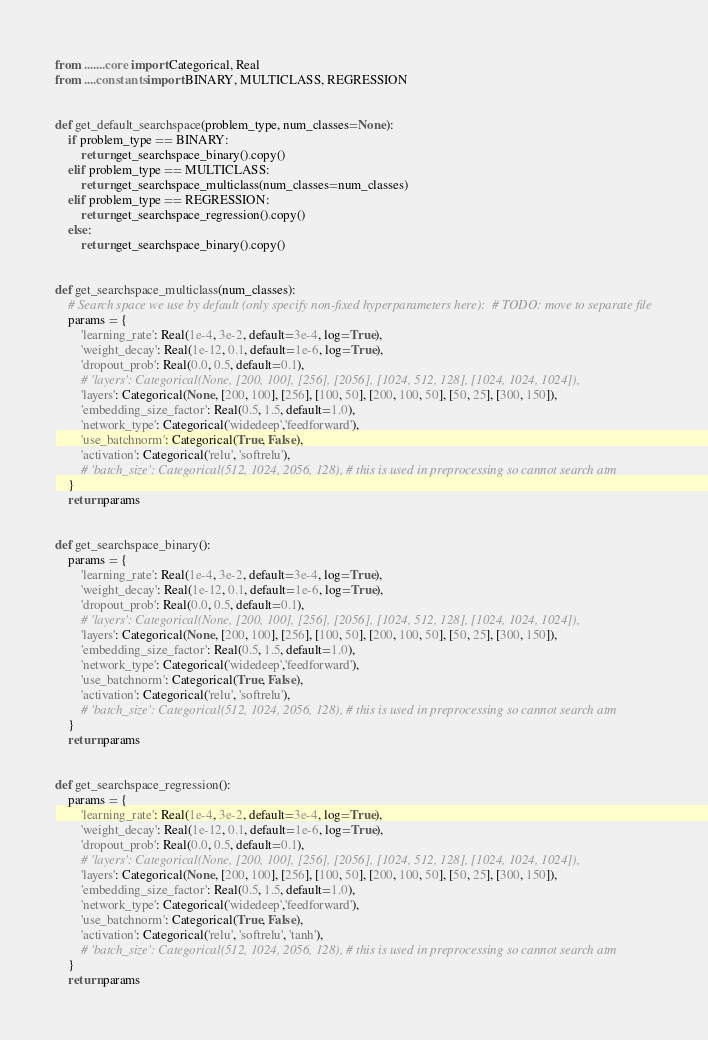<code> <loc_0><loc_0><loc_500><loc_500><_Python_>from .......core import Categorical, Real
from ....constants import BINARY, MULTICLASS, REGRESSION


def get_default_searchspace(problem_type, num_classes=None):
    if problem_type == BINARY:
        return get_searchspace_binary().copy()
    elif problem_type == MULTICLASS:
        return get_searchspace_multiclass(num_classes=num_classes)
    elif problem_type == REGRESSION:
        return get_searchspace_regression().copy()
    else:
        return get_searchspace_binary().copy()


def get_searchspace_multiclass(num_classes):
    # Search space we use by default (only specify non-fixed hyperparameters here):  # TODO: move to separate file
    params = {
        'learning_rate': Real(1e-4, 3e-2, default=3e-4, log=True),
        'weight_decay': Real(1e-12, 0.1, default=1e-6, log=True),
        'dropout_prob': Real(0.0, 0.5, default=0.1),
        # 'layers': Categorical(None, [200, 100], [256], [2056], [1024, 512, 128], [1024, 1024, 1024]),
        'layers': Categorical(None, [200, 100], [256], [100, 50], [200, 100, 50], [50, 25], [300, 150]),
        'embedding_size_factor': Real(0.5, 1.5, default=1.0),
        'network_type': Categorical('widedeep','feedforward'), 
        'use_batchnorm': Categorical(True, False),
        'activation': Categorical('relu', 'softrelu'),
        # 'batch_size': Categorical(512, 1024, 2056, 128), # this is used in preprocessing so cannot search atm
    }
    return params


def get_searchspace_binary():
    params = {
        'learning_rate': Real(1e-4, 3e-2, default=3e-4, log=True),
        'weight_decay': Real(1e-12, 0.1, default=1e-6, log=True),
        'dropout_prob': Real(0.0, 0.5, default=0.1),
        # 'layers': Categorical(None, [200, 100], [256], [2056], [1024, 512, 128], [1024, 1024, 1024]),
        'layers': Categorical(None, [200, 100], [256], [100, 50], [200, 100, 50], [50, 25], [300, 150]),
        'embedding_size_factor': Real(0.5, 1.5, default=1.0),
        'network_type': Categorical('widedeep','feedforward'), 
        'use_batchnorm': Categorical(True, False),
        'activation': Categorical('relu', 'softrelu'),
        # 'batch_size': Categorical(512, 1024, 2056, 128), # this is used in preprocessing so cannot search atm
    }
    return params


def get_searchspace_regression():
    params = {
        'learning_rate': Real(1e-4, 3e-2, default=3e-4, log=True),
        'weight_decay': Real(1e-12, 0.1, default=1e-6, log=True),
        'dropout_prob': Real(0.0, 0.5, default=0.1),
        # 'layers': Categorical(None, [200, 100], [256], [2056], [1024, 512, 128], [1024, 1024, 1024]),
        'layers': Categorical(None, [200, 100], [256], [100, 50], [200, 100, 50], [50, 25], [300, 150]),
        'embedding_size_factor': Real(0.5, 1.5, default=1.0),
        'network_type': Categorical('widedeep','feedforward'), 
        'use_batchnorm': Categorical(True, False),
        'activation': Categorical('relu', 'softrelu', 'tanh'),
        # 'batch_size': Categorical(512, 1024, 2056, 128), # this is used in preprocessing so cannot search atm
    }
    return params
</code> 